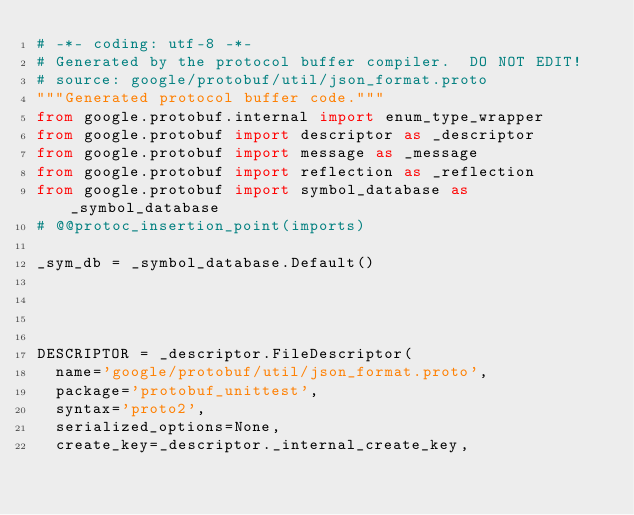Convert code to text. <code><loc_0><loc_0><loc_500><loc_500><_Python_># -*- coding: utf-8 -*-
# Generated by the protocol buffer compiler.  DO NOT EDIT!
# source: google/protobuf/util/json_format.proto
"""Generated protocol buffer code."""
from google.protobuf.internal import enum_type_wrapper
from google.protobuf import descriptor as _descriptor
from google.protobuf import message as _message
from google.protobuf import reflection as _reflection
from google.protobuf import symbol_database as _symbol_database
# @@protoc_insertion_point(imports)

_sym_db = _symbol_database.Default()




DESCRIPTOR = _descriptor.FileDescriptor(
  name='google/protobuf/util/json_format.proto',
  package='protobuf_unittest',
  syntax='proto2',
  serialized_options=None,
  create_key=_descriptor._internal_create_key,</code> 